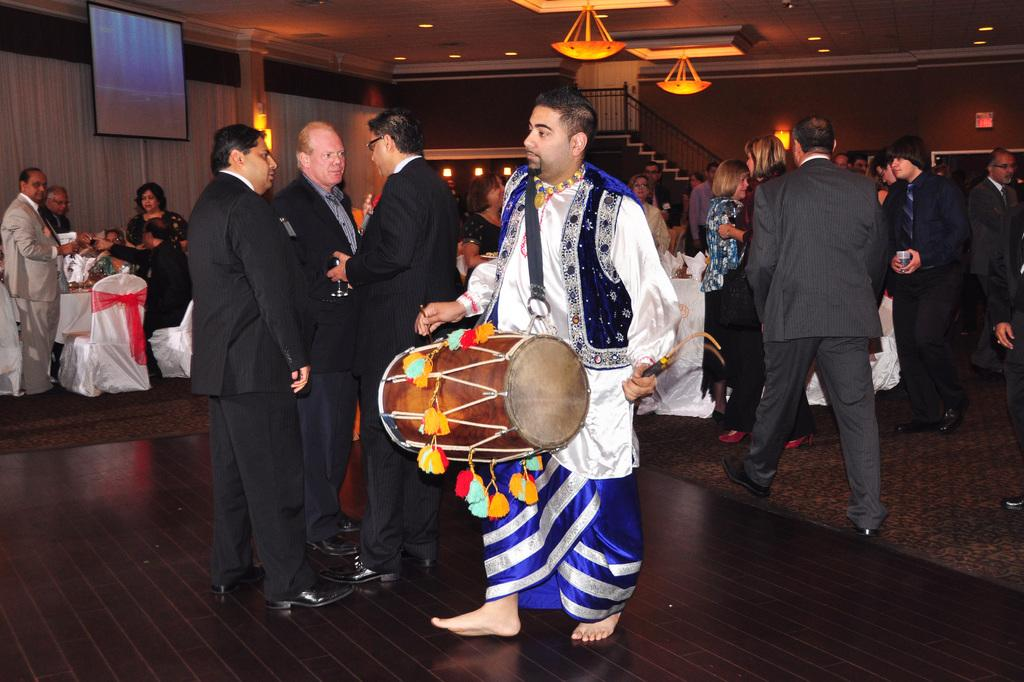What is the main subject of the image? The main subject of the image is a group of people. What are the people in the image doing? The people are standing. Can you identify any specific individual in the image? Yes, there is a man in the image. What is the man doing in the image? The man is playing drums. What year is depicted in the image? The provided facts do not mention any specific year, so it cannot be determined from the image. 